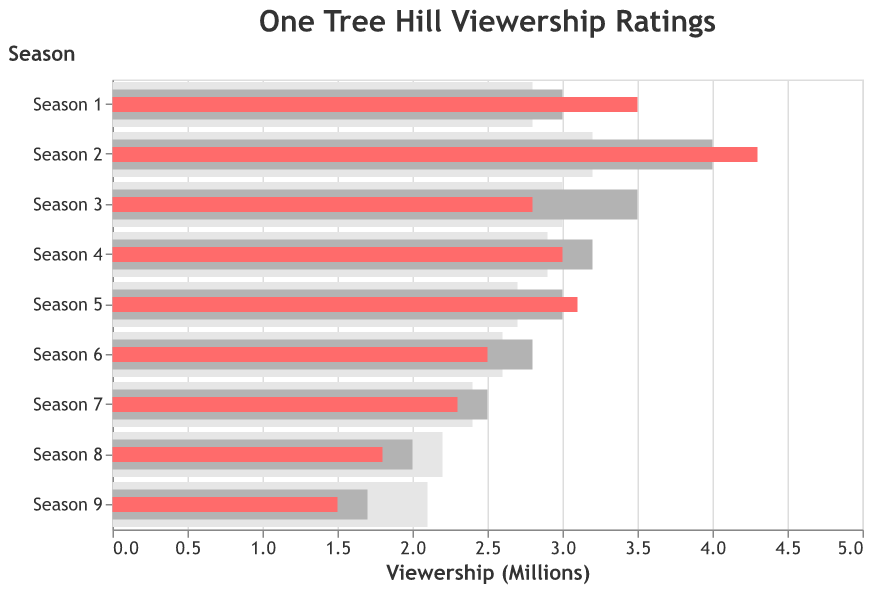What's the title of the figure? The title is displayed prominently at the top of the figure. It reads "One Tree Hill Viewership Ratings".
Answer: One Tree Hill Viewership Ratings What does the light gray (e6e6e6) bar represent? The light gray bar represents the "Network Average (Millions)" viewership for each season of One Tree Hill.
Answer: Network Average (Millions) Which season had the highest actual viewership? By observing the red bars representing actual viewership, the highest is in Season 2.
Answer: Season 2 How does Season 5's actual viewership compare to its target viewership? By comparing the red and dark gray bars for Season 5, the actual viewership (3.1 million) is slightly above the target viewership (3.0 million).
Answer: Slightly above For which seasons did actual viewership exceed the target viewership? Observing the red bars compared to dark gray bars, actual viewership exceeded target viewership in Season 1, Season 2, and Season 5.
Answer: Season 1, Season 2, Season 5 Which season had the lowest actual viewership and how did it compare to the network average? The shortest red bar represents Season 9 with 1.5 million viewers. The light gray bar indicates the network average was 2.1 million, higher than the actual viewership.
Answer: Season 9, lower In which seasons was the actual viewership lower than the network average? Comparing red and light gray bars, actual viewership was lower than network average in Season 8 and Season 9.
Answer: Season 8, Season 9 What is the difference between actual and target viewership for Season 6? The red bar for actual viewership is at 2.5 million, while the dark gray bar for target is at 2.8 million. The difference is 2.8 - 2.5 = 0.3 million.
Answer: 0.3 million Calculate the average actual viewership over all nine seasons? Sum all actual viewership values (3.5 + 4.3 + 2.8 + 3.0 + 3.1 + 2.5 + 2.3 + 1.8 + 1.5) which equals 24.8 million. Divide by 9. 24.8 / 9 = 2.756 million.
Answer: 2.76 million (rounded to 2 decimal places) 